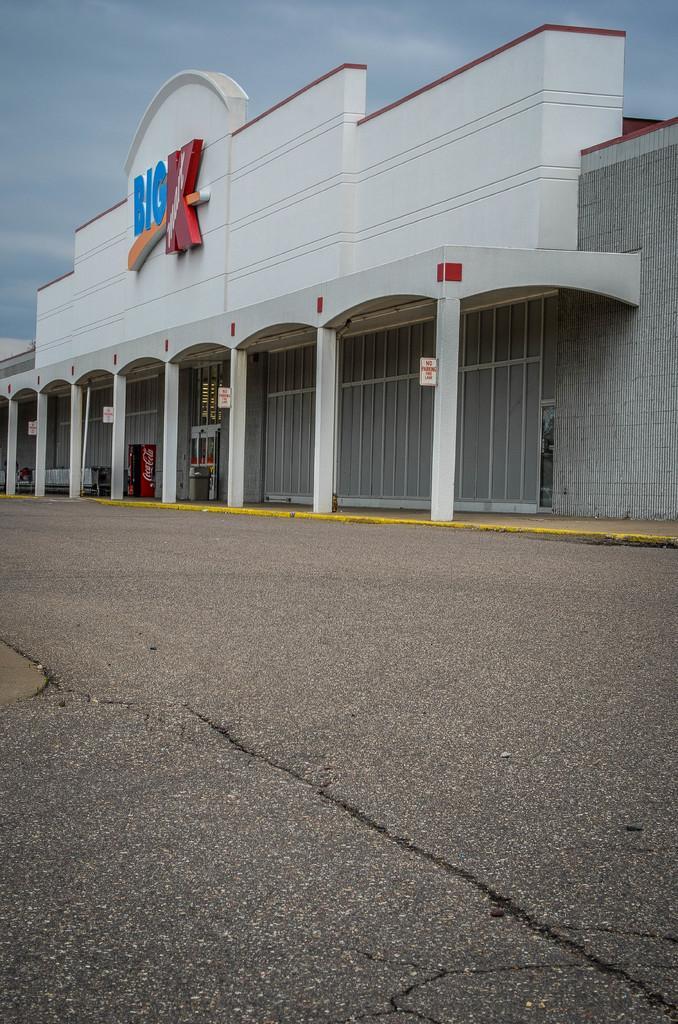Please provide a concise description of this image. In this image I can see road, a building, few boards, the sky and here I can see something is written. 